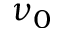Convert formula to latex. <formula><loc_0><loc_0><loc_500><loc_500>\nu _ { 0 }</formula> 